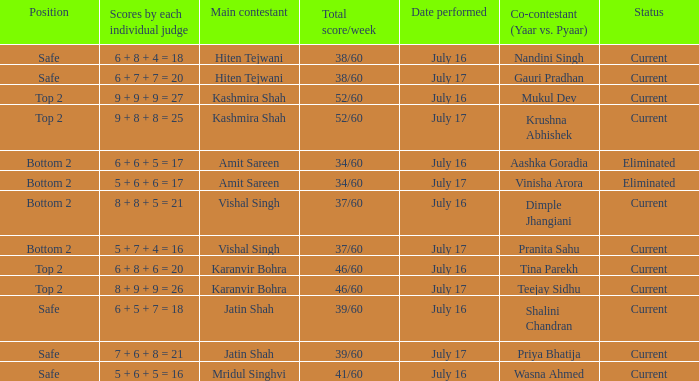What position did the team with the total score of 41/60 get? Safe. Help me parse the entirety of this table. {'header': ['Position', 'Scores by each individual judge', 'Main contestant', 'Total score/week', 'Date performed', 'Co-contestant (Yaar vs. Pyaar)', 'Status'], 'rows': [['Safe', '6 + 8 + 4 = 18', 'Hiten Tejwani', '38/60', 'July 16', 'Nandini Singh', 'Current'], ['Safe', '6 + 7 + 7 = 20', 'Hiten Tejwani', '38/60', 'July 17', 'Gauri Pradhan', 'Current'], ['Top 2', '9 + 9 + 9 = 27', 'Kashmira Shah', '52/60', 'July 16', 'Mukul Dev', 'Current'], ['Top 2', '9 + 8 + 8 = 25', 'Kashmira Shah', '52/60', 'July 17', 'Krushna Abhishek', 'Current'], ['Bottom 2', '6 + 6 + 5 = 17', 'Amit Sareen', '34/60', 'July 16', 'Aashka Goradia', 'Eliminated'], ['Bottom 2', '5 + 6 + 6 = 17', 'Amit Sareen', '34/60', 'July 17', 'Vinisha Arora', 'Eliminated'], ['Bottom 2', '8 + 8 + 5 = 21', 'Vishal Singh', '37/60', 'July 16', 'Dimple Jhangiani', 'Current'], ['Bottom 2', '5 + 7 + 4 = 16', 'Vishal Singh', '37/60', 'July 17', 'Pranita Sahu', 'Current'], ['Top 2', '6 + 8 + 6 = 20', 'Karanvir Bohra', '46/60', 'July 16', 'Tina Parekh', 'Current'], ['Top 2', '8 + 9 + 9 = 26', 'Karanvir Bohra', '46/60', 'July 17', 'Teejay Sidhu', 'Current'], ['Safe', '6 + 5 + 7 = 18', 'Jatin Shah', '39/60', 'July 16', 'Shalini Chandran', 'Current'], ['Safe', '7 + 6 + 8 = 21', 'Jatin Shah', '39/60', 'July 17', 'Priya Bhatija', 'Current'], ['Safe', '5 + 6 + 5 = 16', 'Mridul Singhvi', '41/60', 'July 16', 'Wasna Ahmed', 'Current']]} 